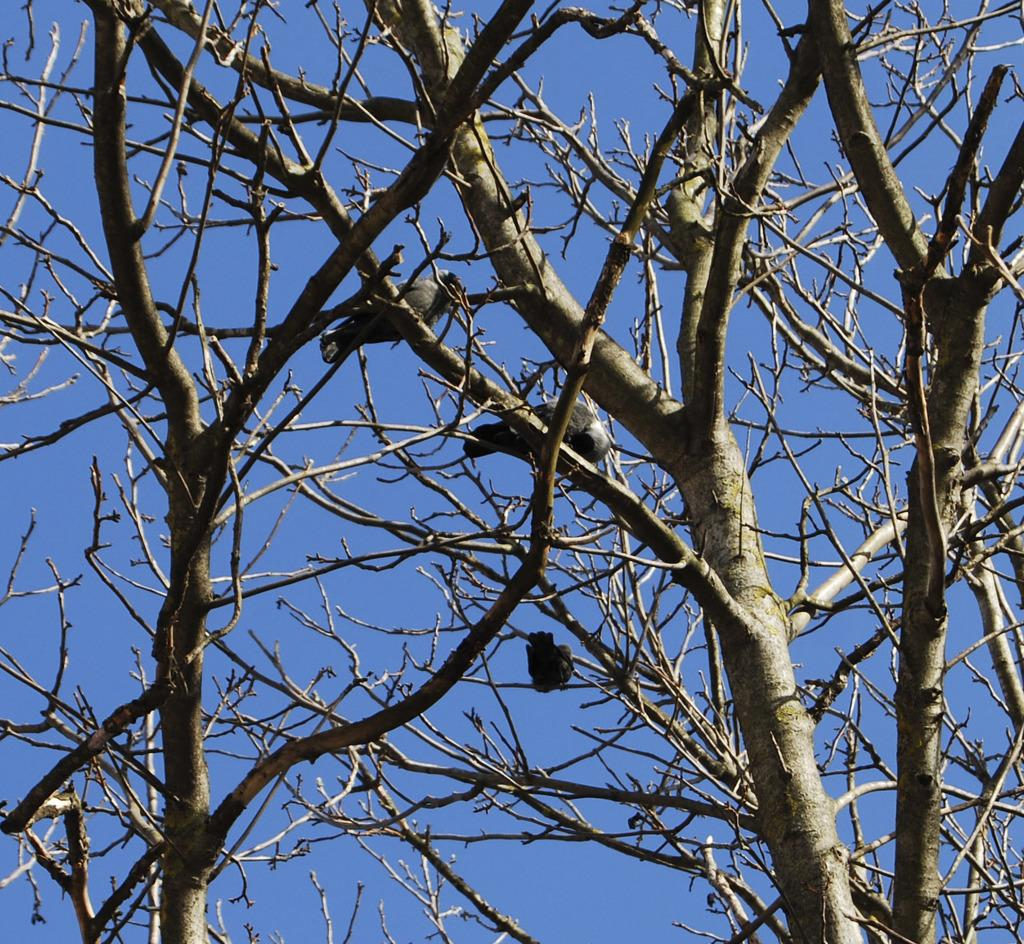What type of animals can be seen in the image? There are birds in the image. Where are the birds located? The birds are on dry trees. What color is the sky in the image? The sky is blue in color. What type of shoes can be seen hanging from the branches of the trees in the image? There are no shoes present in the image; it features birds on dry trees with a blue sky. 